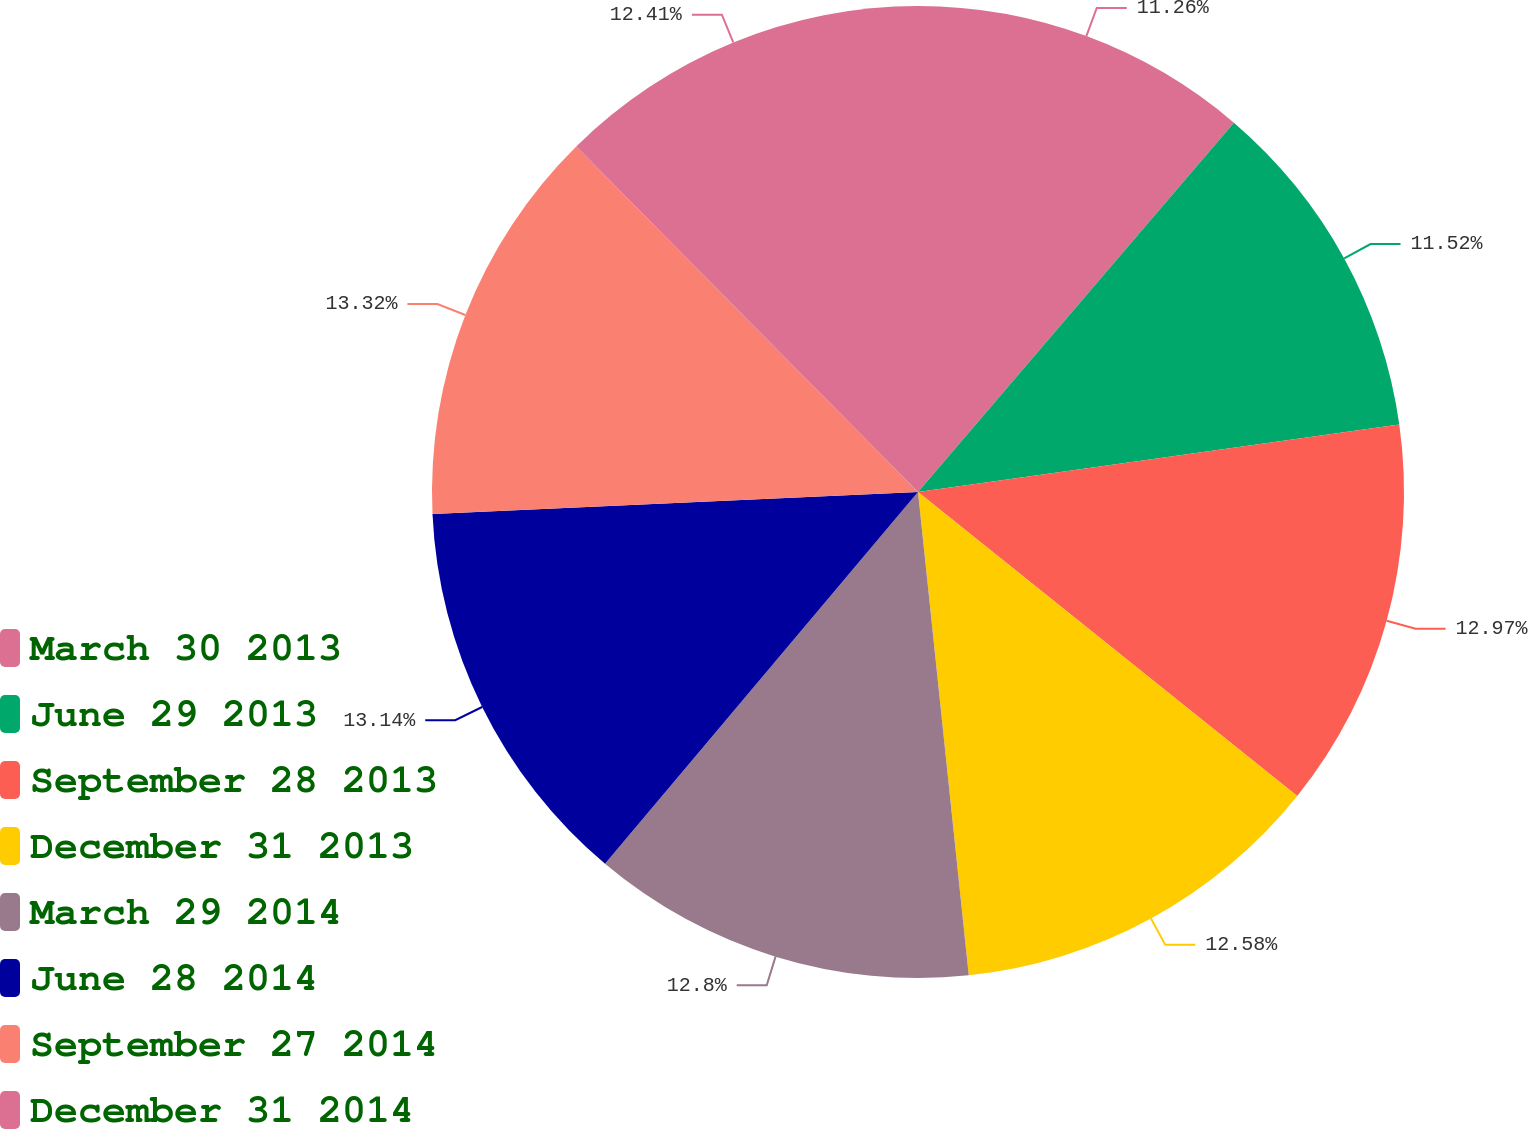Convert chart to OTSL. <chart><loc_0><loc_0><loc_500><loc_500><pie_chart><fcel>March 30 2013<fcel>June 29 2013<fcel>September 28 2013<fcel>December 31 2013<fcel>March 29 2014<fcel>June 28 2014<fcel>September 27 2014<fcel>December 31 2014<nl><fcel>11.26%<fcel>11.52%<fcel>12.97%<fcel>12.58%<fcel>12.8%<fcel>13.14%<fcel>13.31%<fcel>12.41%<nl></chart> 